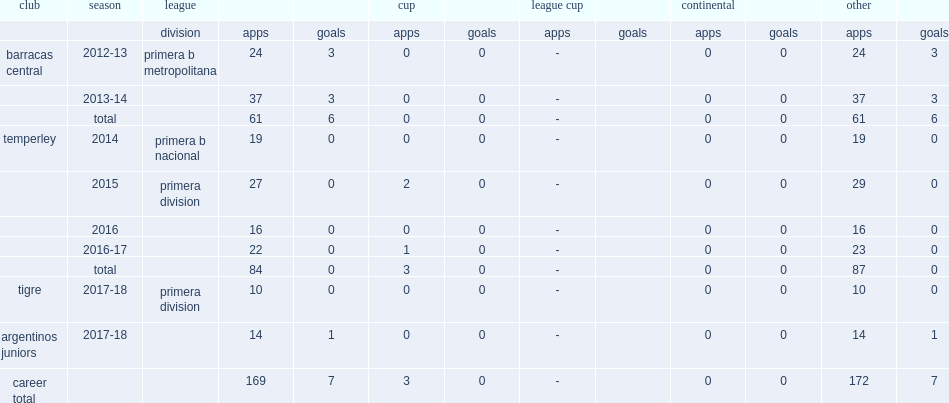Which club did bojanich play for in 2014? Temperley. 